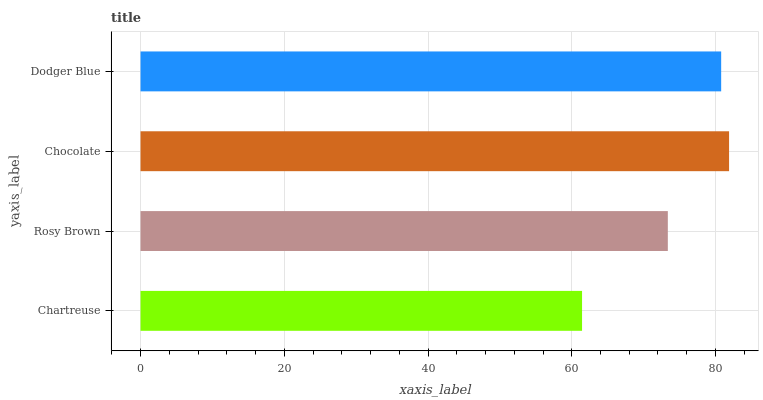Is Chartreuse the minimum?
Answer yes or no. Yes. Is Chocolate the maximum?
Answer yes or no. Yes. Is Rosy Brown the minimum?
Answer yes or no. No. Is Rosy Brown the maximum?
Answer yes or no. No. Is Rosy Brown greater than Chartreuse?
Answer yes or no. Yes. Is Chartreuse less than Rosy Brown?
Answer yes or no. Yes. Is Chartreuse greater than Rosy Brown?
Answer yes or no. No. Is Rosy Brown less than Chartreuse?
Answer yes or no. No. Is Dodger Blue the high median?
Answer yes or no. Yes. Is Rosy Brown the low median?
Answer yes or no. Yes. Is Chartreuse the high median?
Answer yes or no. No. Is Dodger Blue the low median?
Answer yes or no. No. 